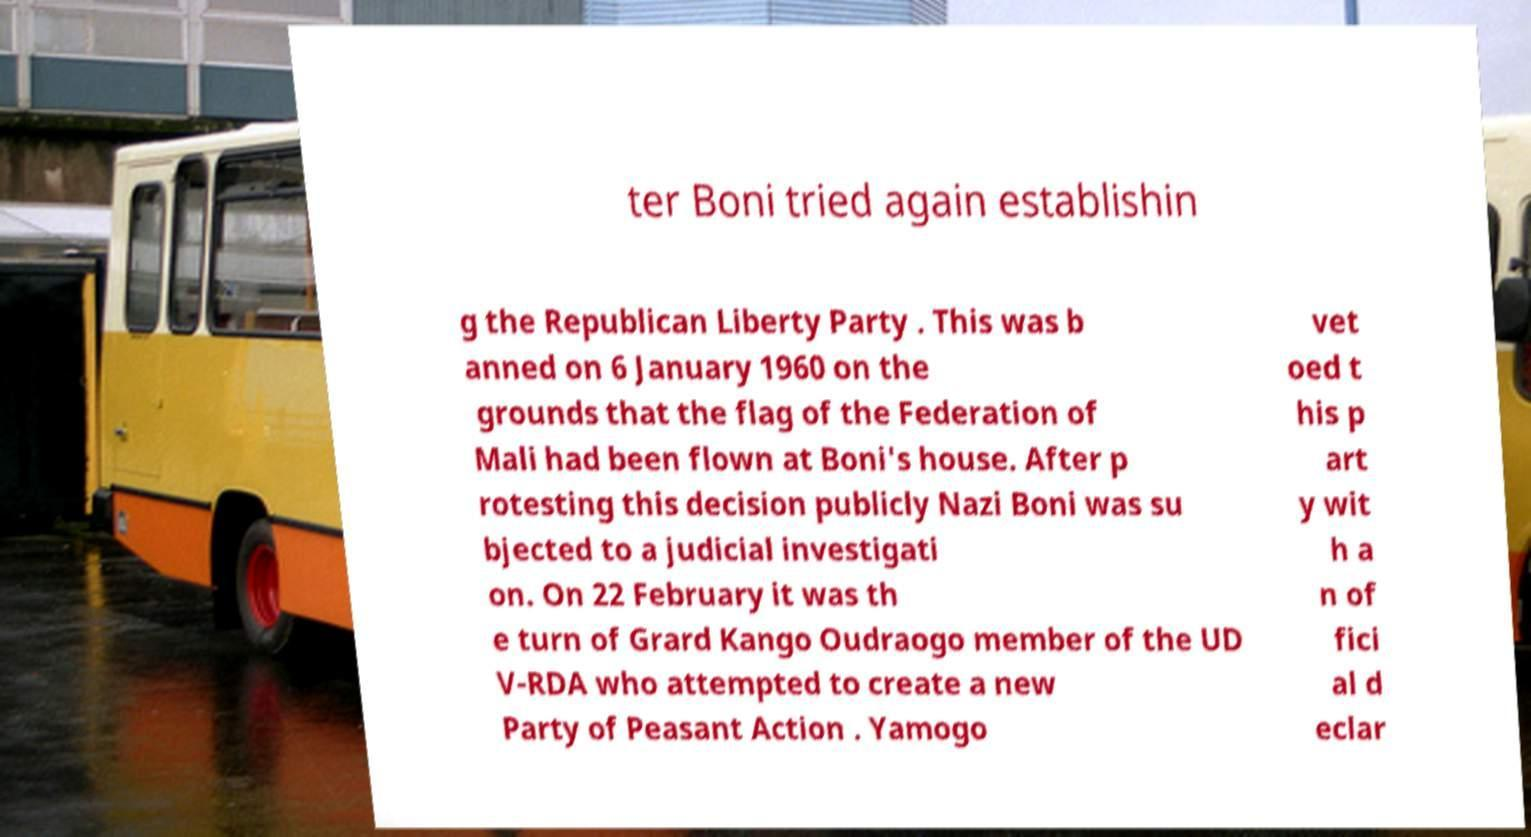Can you accurately transcribe the text from the provided image for me? ter Boni tried again establishin g the Republican Liberty Party . This was b anned on 6 January 1960 on the grounds that the flag of the Federation of Mali had been flown at Boni's house. After p rotesting this decision publicly Nazi Boni was su bjected to a judicial investigati on. On 22 February it was th e turn of Grard Kango Oudraogo member of the UD V-RDA who attempted to create a new Party of Peasant Action . Yamogo vet oed t his p art y wit h a n of fici al d eclar 